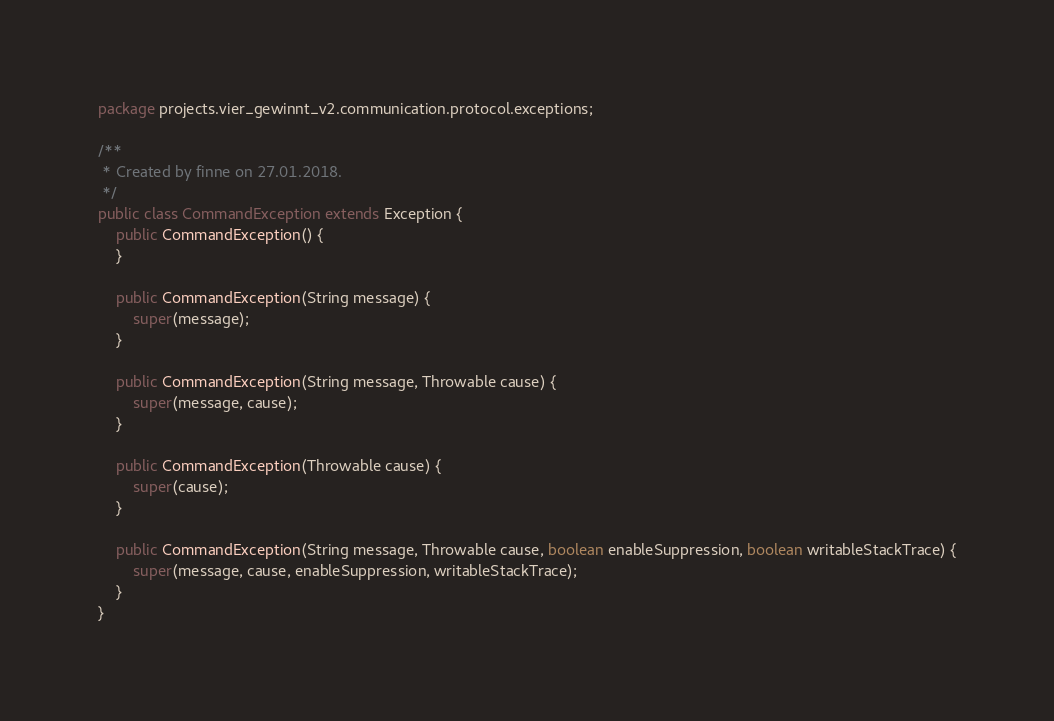<code> <loc_0><loc_0><loc_500><loc_500><_Java_>package projects.vier_gewinnt_v2.communication.protocol.exceptions;

/**
 * Created by finne on 27.01.2018.
 */
public class CommandException extends Exception {
    public CommandException() {
    }

    public CommandException(String message) {
        super(message);
    }

    public CommandException(String message, Throwable cause) {
        super(message, cause);
    }

    public CommandException(Throwable cause) {
        super(cause);
    }

    public CommandException(String message, Throwable cause, boolean enableSuppression, boolean writableStackTrace) {
        super(message, cause, enableSuppression, writableStackTrace);
    }
}
</code> 